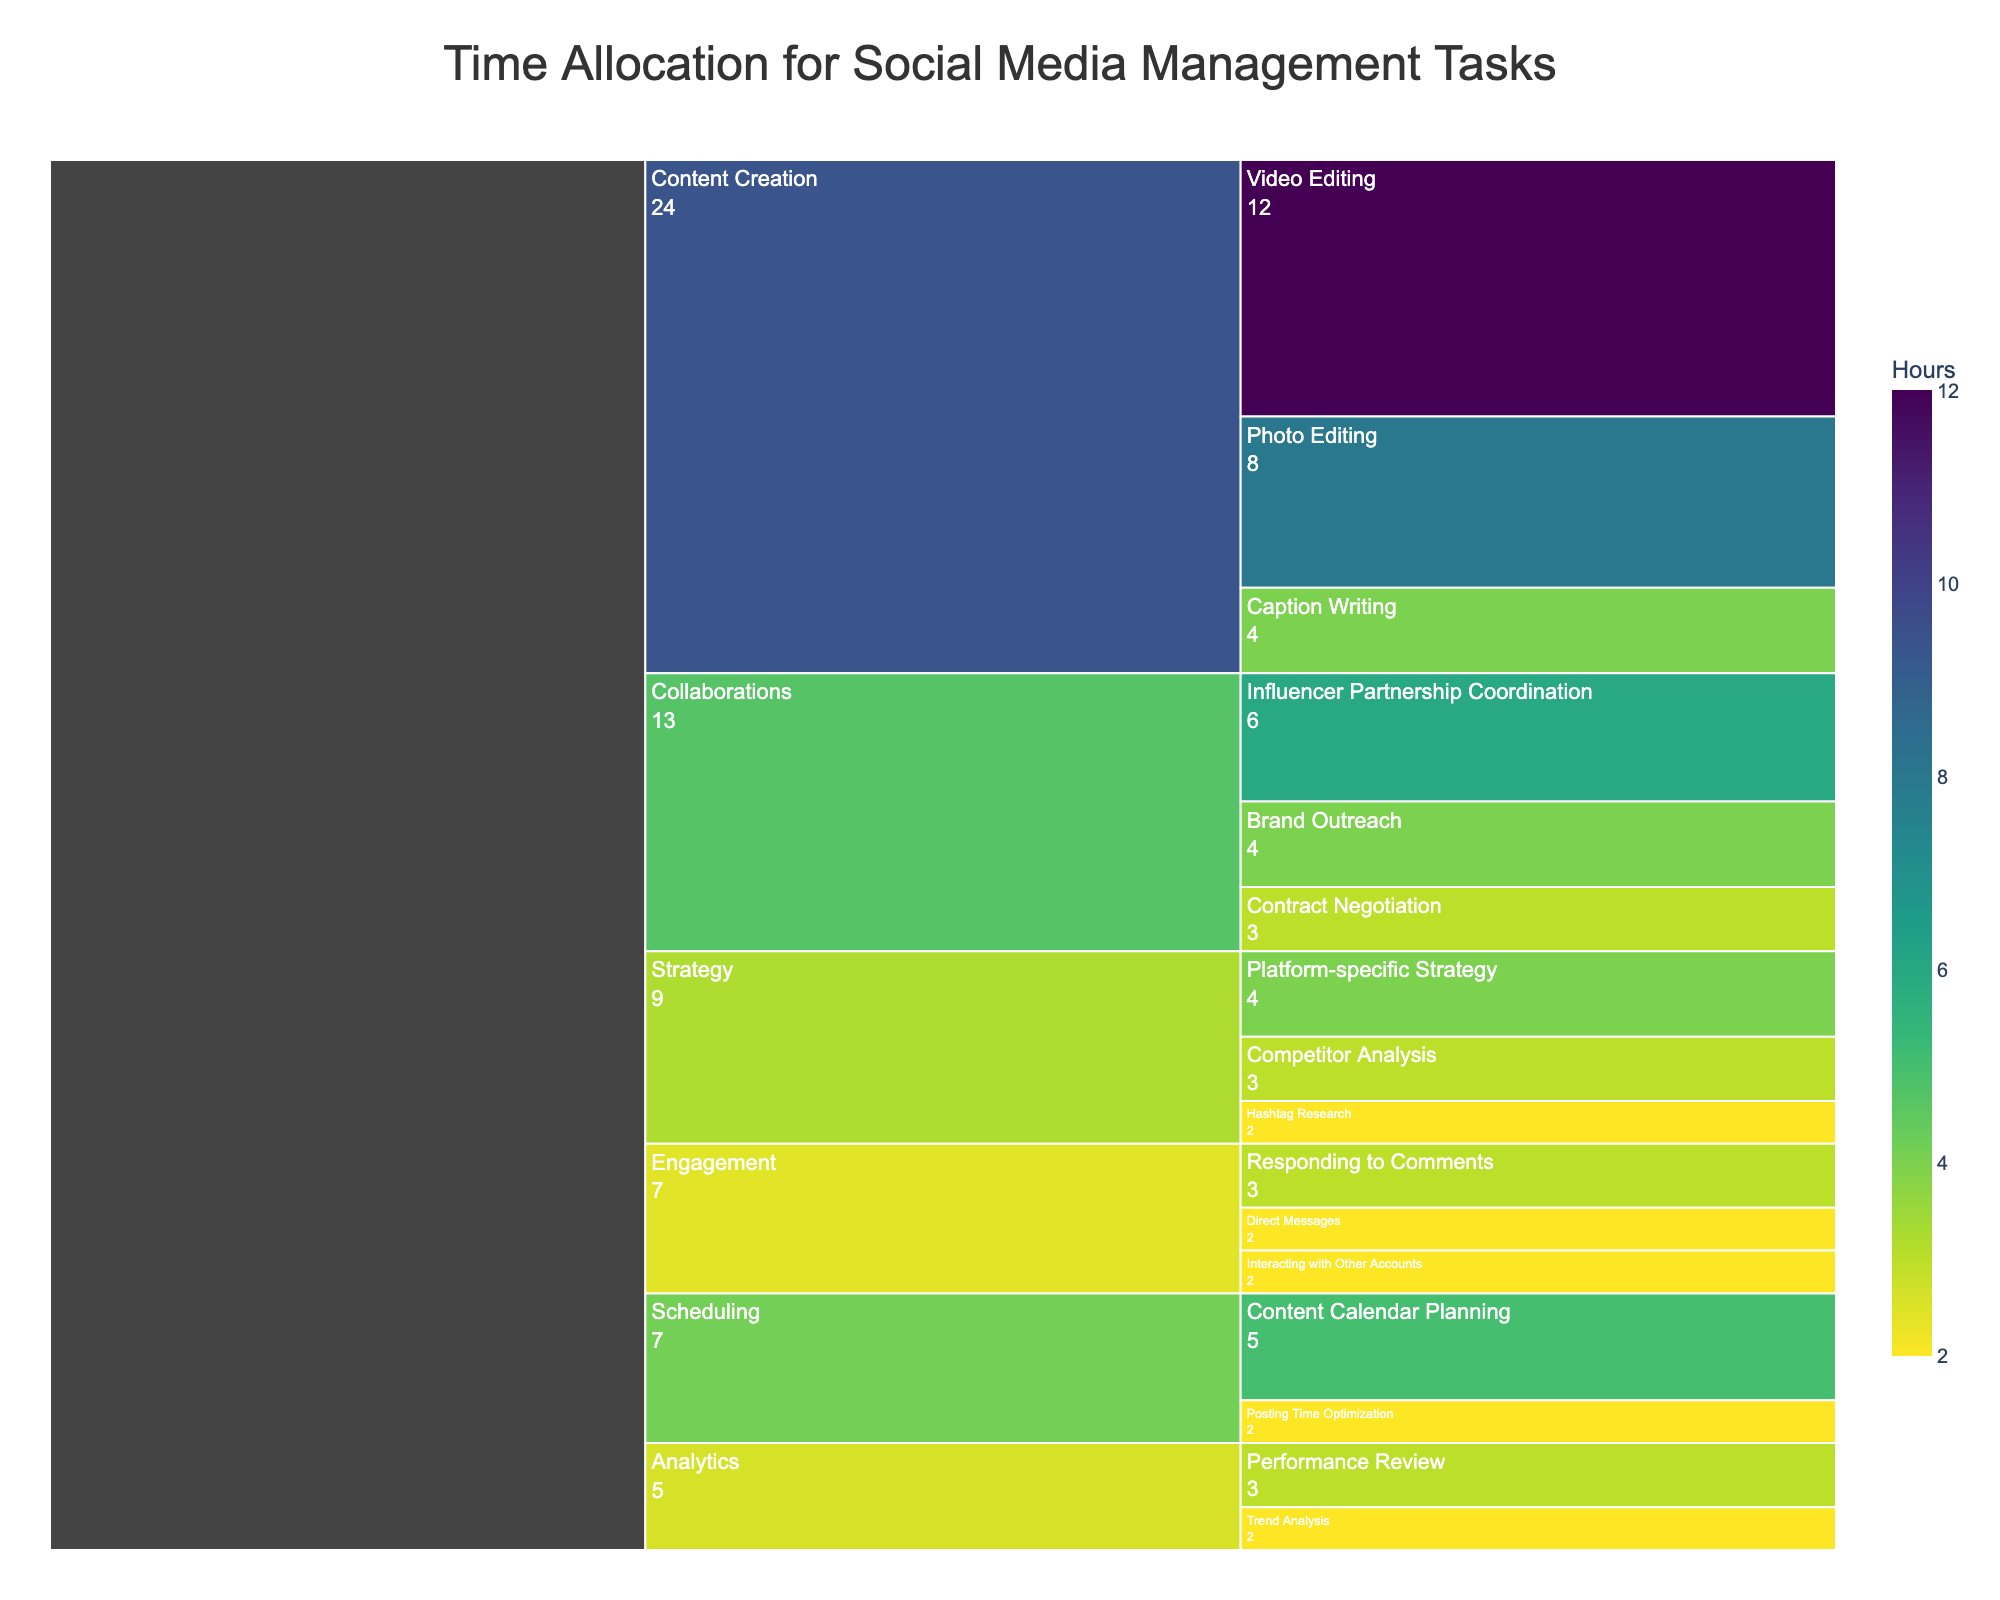Which task consumes the most time overall? To find the task that consumes the most time, look at the sections with the largest values in the Icicle Chart. The "Content Creation" task should have a high sum of its subtask times since it includes Photo Editing, Video Editing, and Caption Writing. Summing these values gives 24 hours, which is the highest.
Answer: Content Creation How much time is spent on Analytics tasks in total? Add the time spent on Performance Review and Trend Analysis. The sum is 3 hours + 2 hours.
Answer: 5 hours Which subtask takes the most time under the "Collaborations" task? Look under the "Collaborations" section and compare the times of Brand Outreach, Influencer Partnership Coordination, and Contract Negotiation. Influencer Partnership Coordination has the highest value of 6 hours.
Answer: Influencer Partnership Coordination Is more time spent on Engagement or Scheduling? Sum the times of the subtasks under Engagement (3 + 2 + 2) and Scheduling (5 + 2). Engagement totals 7 hours while Scheduling totals 7 hours. Both are equal.
Answer: Equal What is the least time-consuming task? Compare the total times of each main task. The Strategy task appears to have the smallest total with the sum of 4 + 2 + 3, which equals 9 hours. This is less time than other tasks.
Answer: Strategy Which specific subtask consumes 8 hours? Look for a subtask with 8 hours in the Icicle Chart. Photo Editing under Content Creation takes exactly 8 hours.
Answer: Photo Editing How much more time is spent on Content Calendar Planning compared to Hashtag Research? Content Calendar Planning (5 hours) minus Hashtag Research (2 hours) equals 3 hours more.
Answer: 3 hours What is the total time allocated to all tasks? Sum all the times of each task and subtask. The total is given by adding all the provided times: 8 + 12 + 4 + 3 + 2 + 2 + 3 + 2 + 5 + 2 + 4 + 6 + 3 + 4 + 2 + 3 = 61 hours.
Answer: 61 hours How is the time distribution for Influencer Partnership Coordination visualized in comparison to Brand Outreach? In the Icicle Chart, the size of the section for Influencer Partnership Coordination is larger compared to the section for Brand Outreach, indicating it consumes more time. Brand Outreach is 4 hours while Influencer Partnership Coordination is 6 hours.
Answer: Larger 